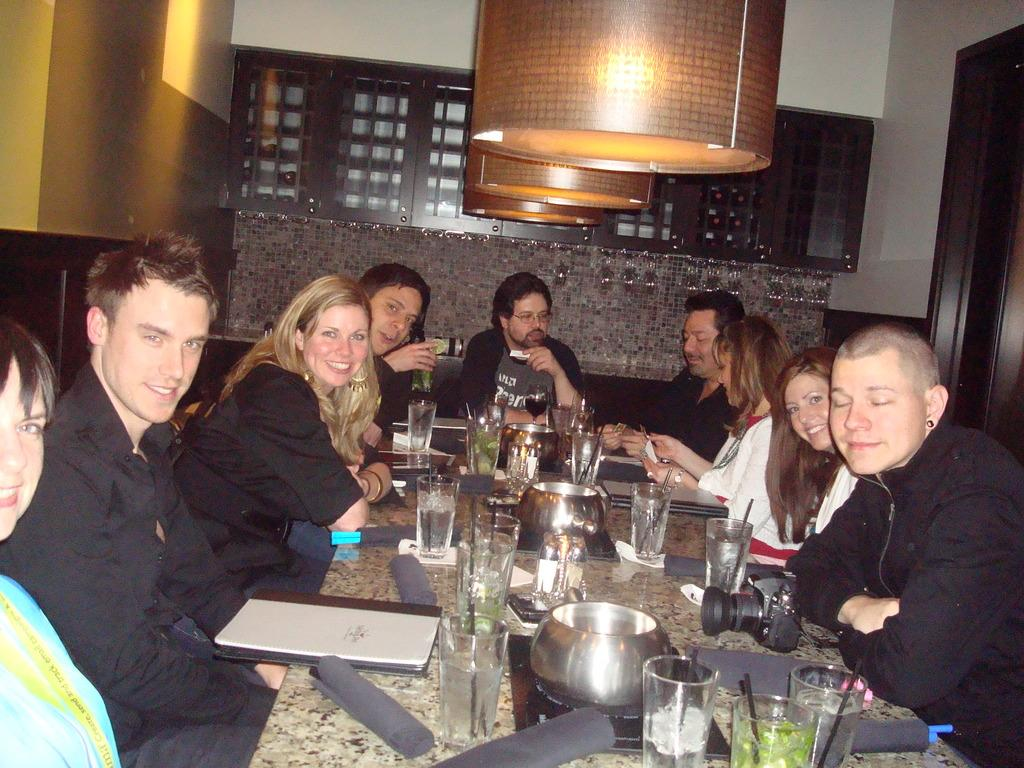What are the people in the image doing? There is a group of people sitting in the image. What can be seen on the table in front of the people? There are glasses and bowls on the table, as well as other things. What is visible in the background of the image? There is a wall in the background. What can be seen at the top of the image? There are lights visible at the top of the image. What type of coal is being used to fuel the ornament in the image? There is no coal or ornament present in the image. What kind of seed is being planted by the people in the image? There is no seed or planting activity depicted in the image. 